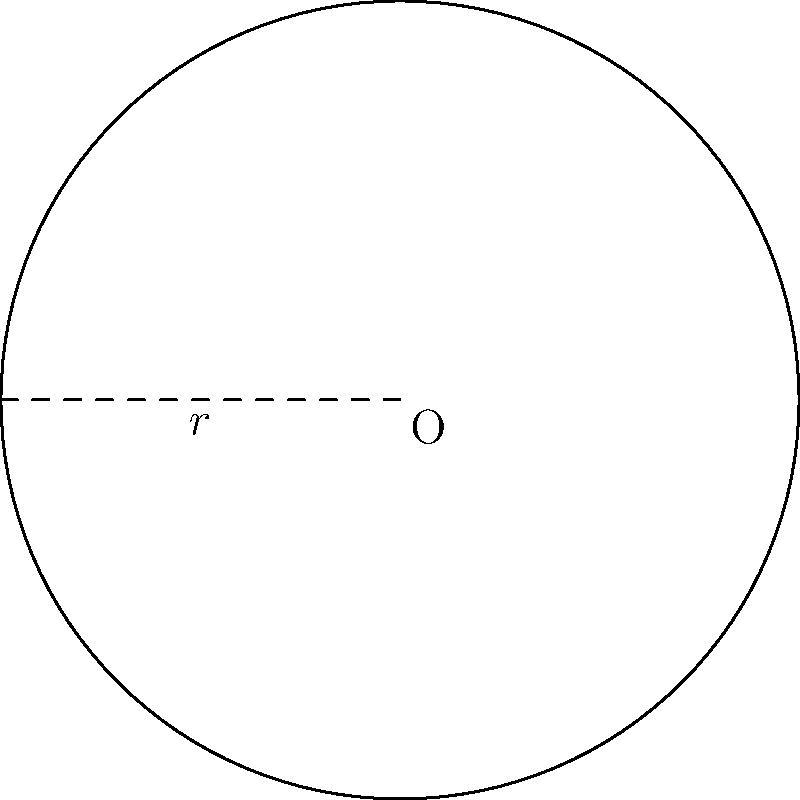At the Bridgestone Arena, home of the Nashville Predators, a circular ice rink needs to be resurfaced. If the radius of the rink is 30 meters, what is the total area that needs to be resurfaced? (Use $\pi = 3.14$ for calculations) To find the area of a circular ice rink, we need to use the formula for the area of a circle:

$$A = \pi r^2$$

Where:
$A$ is the area of the circle
$\pi$ is approximately 3.14
$r$ is the radius of the circle

Given:
- Radius (r) = 30 meters
- $\pi = 3.14$

Let's calculate:

1) Substitute the values into the formula:
   $$A = 3.14 \times 30^2$$

2) Calculate the square of the radius:
   $$A = 3.14 \times 900$$

3) Multiply:
   $$A = 2,826 \text{ square meters}$$

Therefore, the total area of the ice rink that needs to be resurfaced is 2,826 square meters.
Answer: 2,826 square meters 